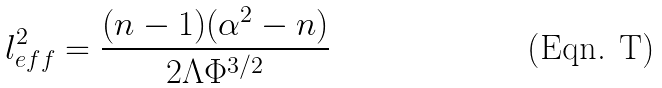<formula> <loc_0><loc_0><loc_500><loc_500>l _ { e f f } ^ { 2 } = \frac { ( n - 1 ) ( \alpha ^ { 2 } - n ) } { 2 \Lambda \Phi ^ { 3 / 2 } }</formula> 